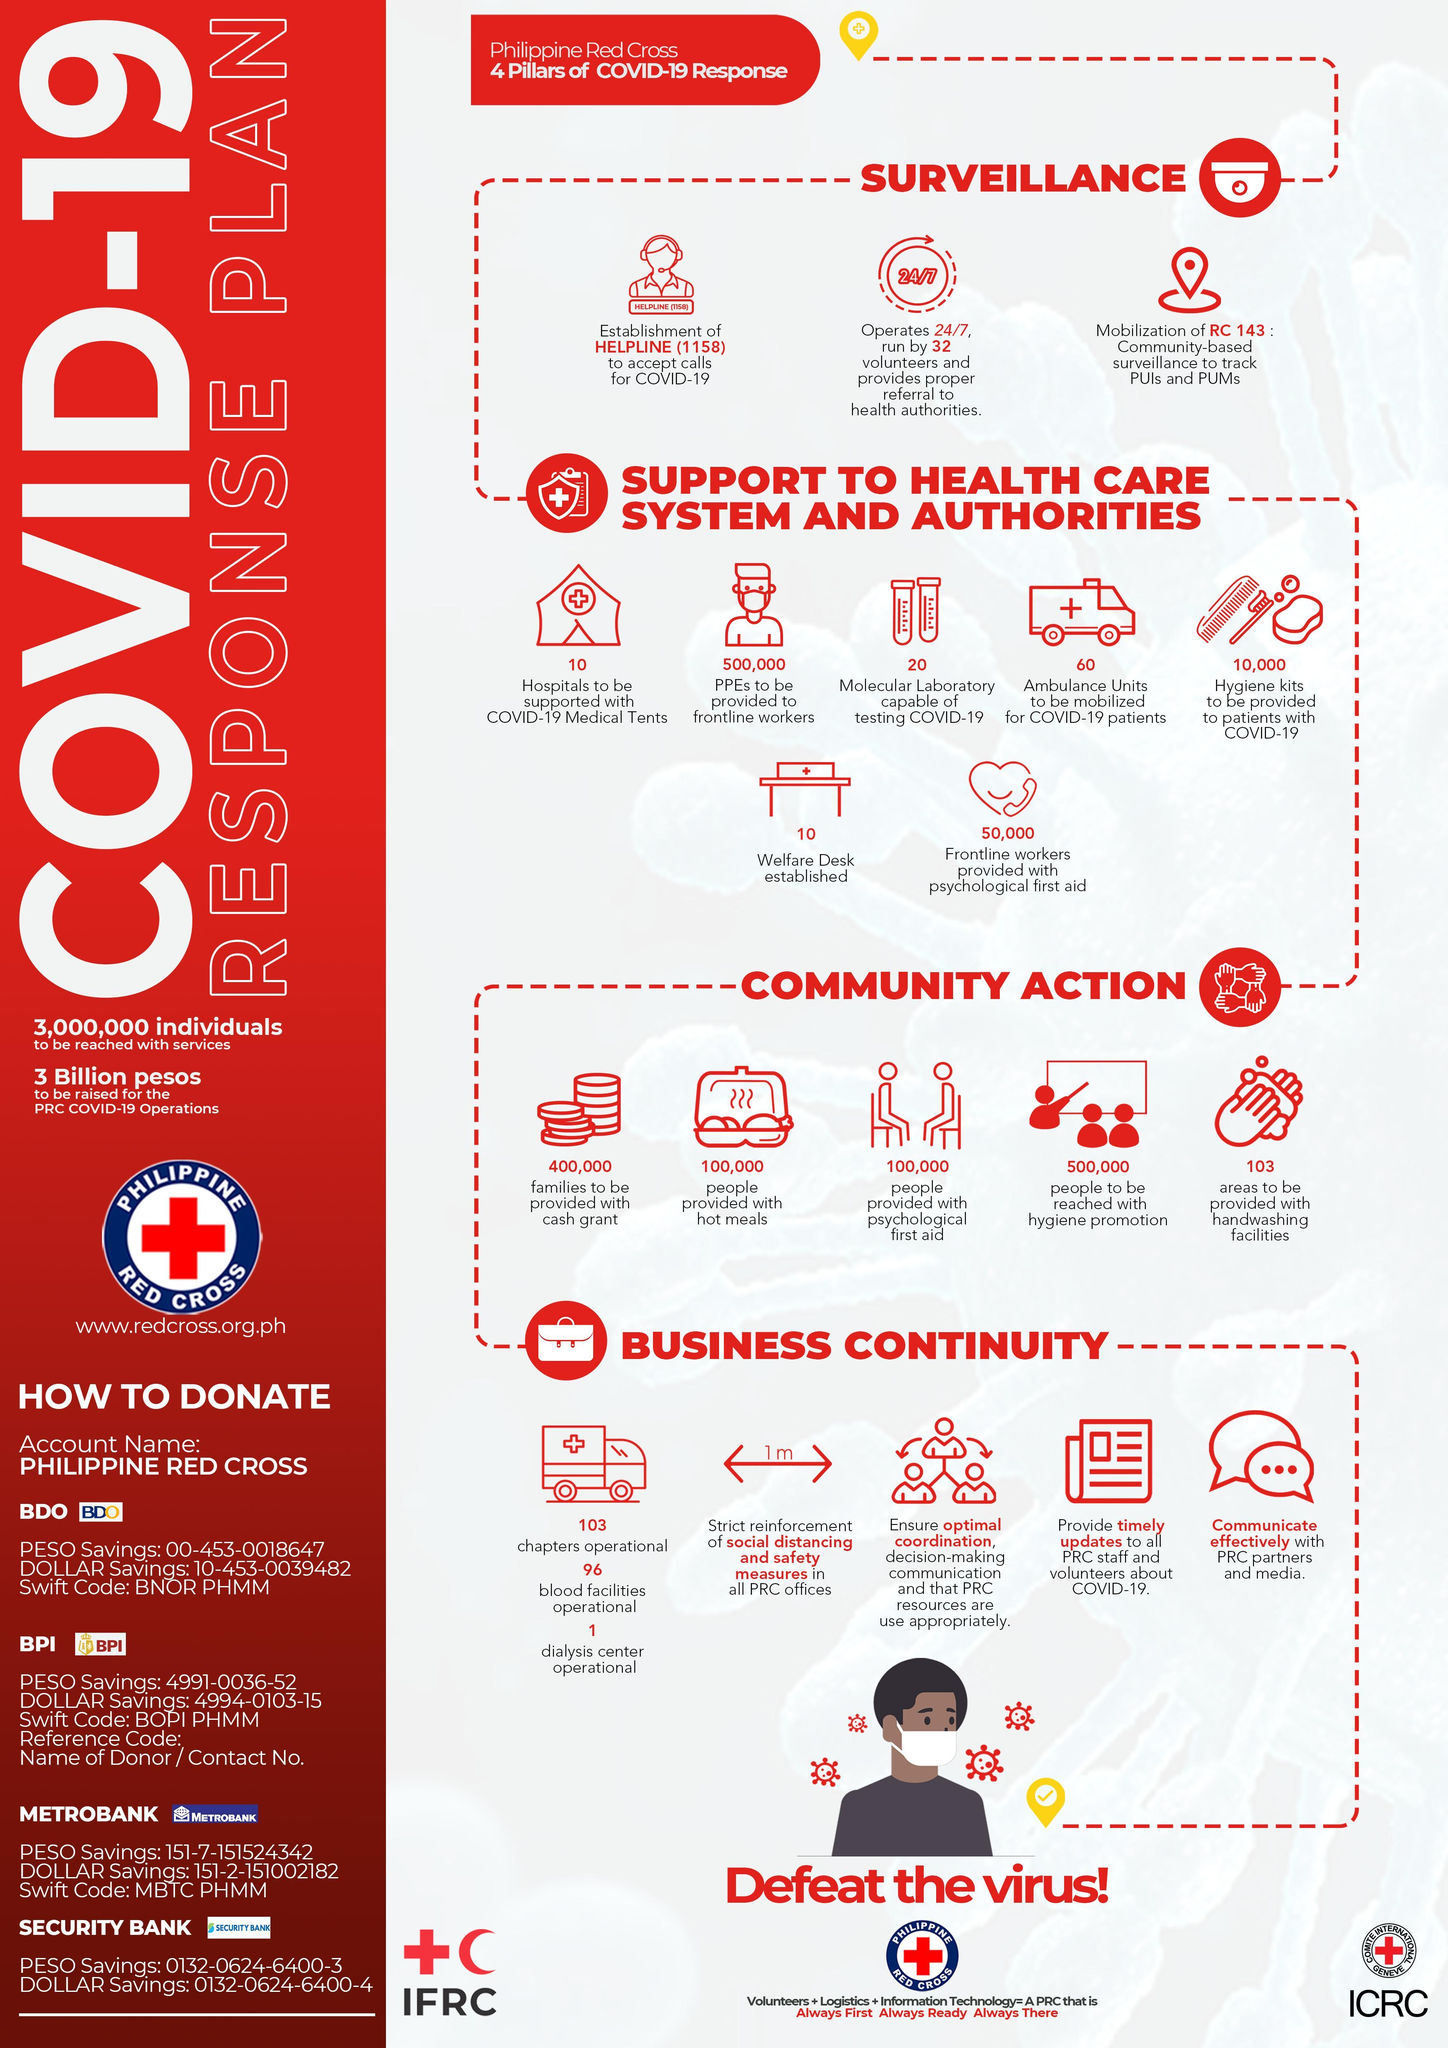How many molecular laboratories are capable of testing COVID-19 in the Philippine Red Cross?
Answer the question with a short phrase. 20 What is the helpline number established to accept calls by the Philippine Red Cross? 1158 What is the number of PPEs to be provided to frontline workers by the Philippine Red Cross? 500,000 What is the number of ambulance units to be mobilized for COVID-19 patients by the Philippine Red Cross? 60 What is the number of areas to be provided with hand washing facilities by the Philippine Red Cross? 103 What is the number of hospitals to be supported with COVID-19 medical tents by the Philippine Red Cross? 10 How many families are to be provided with cash grant by the Philippine Red Cross? 400,000 How many people are provided with psychological first aid by the Philippine Red Cross? 100,000 What is the number of welfare desk established by the Philippine Red Cross? 10 What is the number of people to be provided with hot meals by the Philippine Red Cross? 100,000 